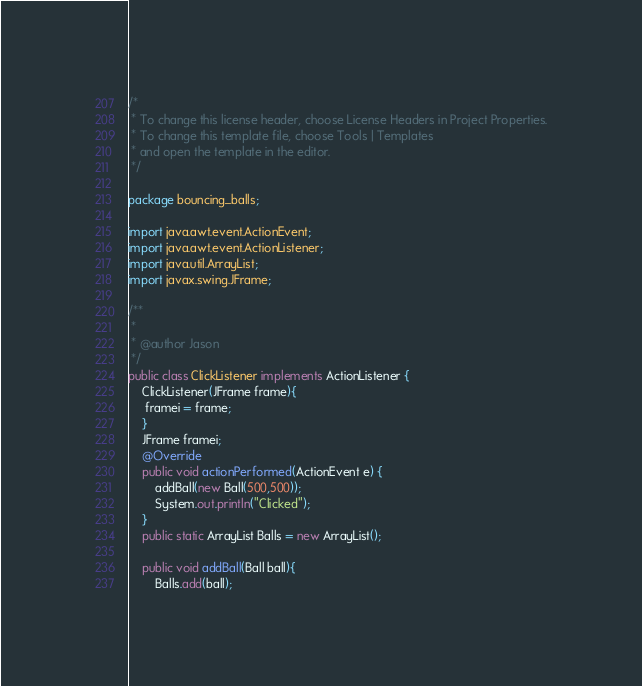Convert code to text. <code><loc_0><loc_0><loc_500><loc_500><_Java_>/*
 * To change this license header, choose License Headers in Project Properties.
 * To change this template file, choose Tools | Templates
 * and open the template in the editor.
 */

package bouncing_balls;

import java.awt.event.ActionEvent;
import java.awt.event.ActionListener;
import java.util.ArrayList;
import javax.swing.JFrame;

/**
 *
 * @author Jason
 */
public class ClickListener implements ActionListener {
    ClickListener(JFrame frame){
     framei = frame;   
    }
    JFrame framei;
    @Override
    public void actionPerformed(ActionEvent e) {
        addBall(new Ball(500,500));
        System.out.println("Clicked");
    }
    public static ArrayList Balls = new ArrayList();
    
    public void addBall(Ball ball){
        Balls.add(ball);</code> 